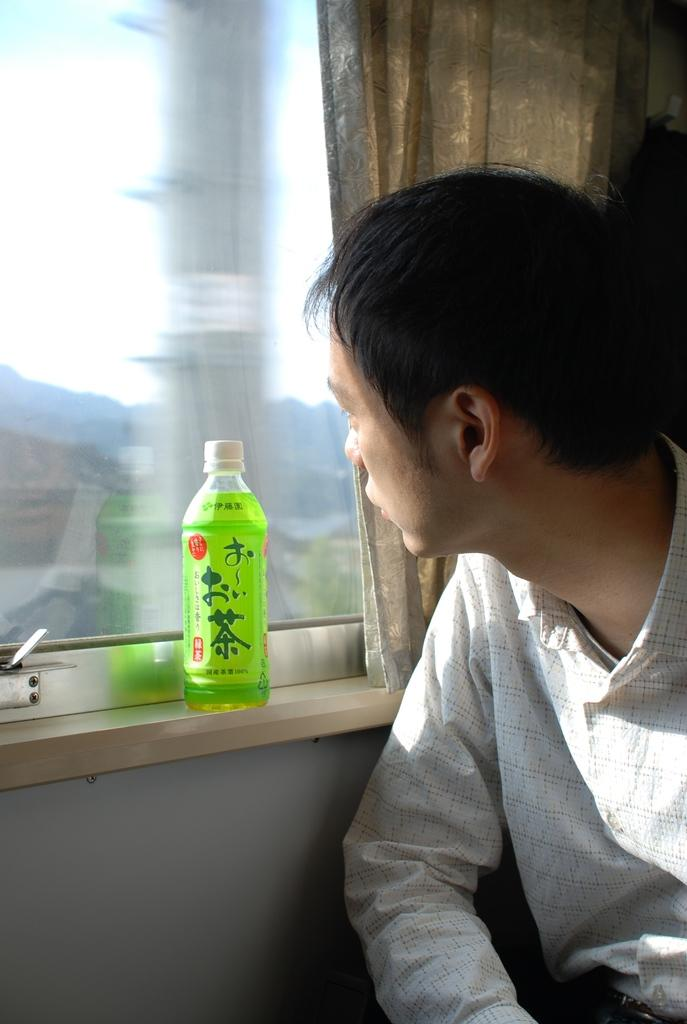What is present in the image? There is a man in the image. What object can be seen in the image besides the man? There is a bottle in the image. What architectural feature is visible in the image? There is a window in the image. What type of window treatment is present in the image? There is a curtain in the image. What type of nose can be seen on the man in the image? There is no nose visible on the man in the image; only his body is shown. What type of eggs are being cooked in the image? There are no eggs present in the image. 